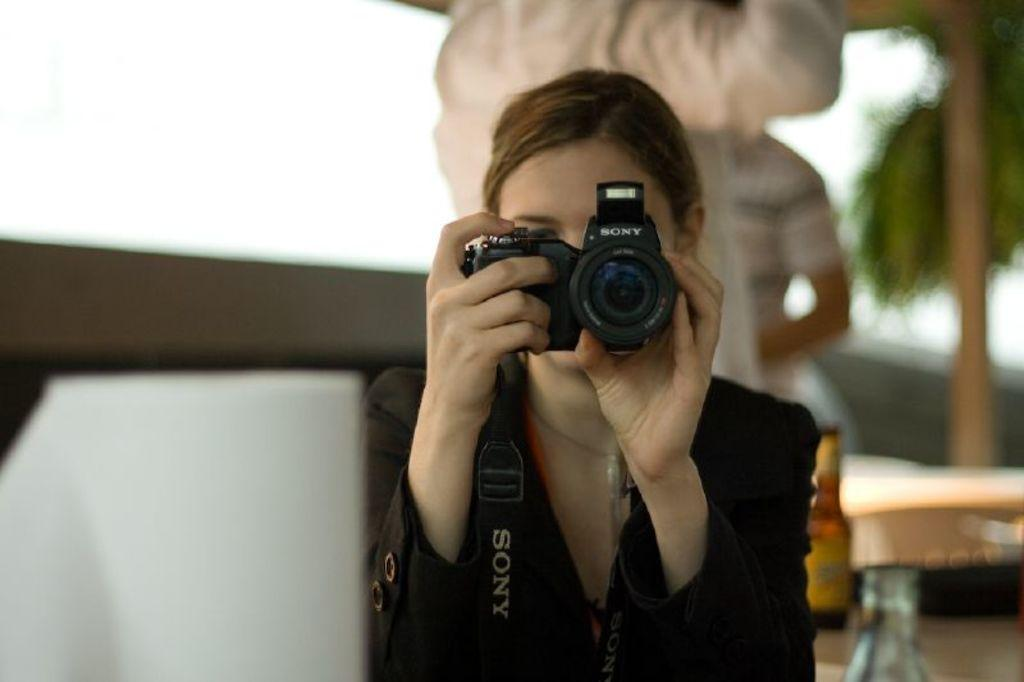Who is the main subject in the image? There is a woman in the image. What is the woman holding in the image? The woman is holding a camera. Can you describe the background of the image? There are two men in the background of the image. What type of books can be seen on the woman's head in the image? There are no books present in the image, and the woman is not holding anything on her head. 